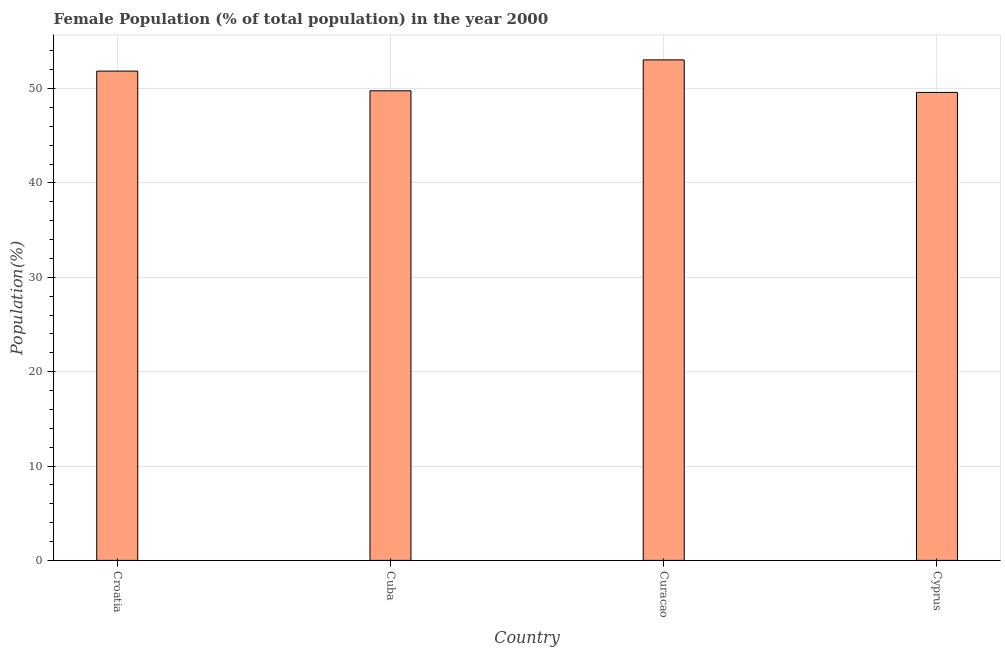Does the graph contain any zero values?
Make the answer very short. No. Does the graph contain grids?
Keep it short and to the point. Yes. What is the title of the graph?
Provide a succinct answer. Female Population (% of total population) in the year 2000. What is the label or title of the X-axis?
Make the answer very short. Country. What is the label or title of the Y-axis?
Ensure brevity in your answer.  Population(%). What is the female population in Cuba?
Ensure brevity in your answer.  49.77. Across all countries, what is the maximum female population?
Give a very brief answer. 53.05. Across all countries, what is the minimum female population?
Provide a short and direct response. 49.6. In which country was the female population maximum?
Your answer should be compact. Curacao. In which country was the female population minimum?
Make the answer very short. Cyprus. What is the sum of the female population?
Your answer should be very brief. 204.27. What is the difference between the female population in Croatia and Cyprus?
Offer a terse response. 2.26. What is the average female population per country?
Your answer should be compact. 51.07. What is the median female population?
Keep it short and to the point. 50.81. In how many countries, is the female population greater than 50 %?
Your response must be concise. 2. What is the ratio of the female population in Croatia to that in Cuba?
Provide a succinct answer. 1.04. Is the difference between the female population in Cuba and Curacao greater than the difference between any two countries?
Offer a very short reply. No. What is the difference between the highest and the second highest female population?
Keep it short and to the point. 1.19. Is the sum of the female population in Croatia and Cyprus greater than the maximum female population across all countries?
Keep it short and to the point. Yes. What is the difference between the highest and the lowest female population?
Provide a short and direct response. 3.45. In how many countries, is the female population greater than the average female population taken over all countries?
Make the answer very short. 2. Are all the bars in the graph horizontal?
Keep it short and to the point. No. What is the difference between two consecutive major ticks on the Y-axis?
Your answer should be compact. 10. What is the Population(%) of Croatia?
Make the answer very short. 51.86. What is the Population(%) in Cuba?
Provide a short and direct response. 49.77. What is the Population(%) in Curacao?
Give a very brief answer. 53.05. What is the Population(%) in Cyprus?
Offer a very short reply. 49.6. What is the difference between the Population(%) in Croatia and Cuba?
Provide a short and direct response. 2.09. What is the difference between the Population(%) in Croatia and Curacao?
Your response must be concise. -1.19. What is the difference between the Population(%) in Croatia and Cyprus?
Give a very brief answer. 2.26. What is the difference between the Population(%) in Cuba and Curacao?
Your response must be concise. -3.27. What is the difference between the Population(%) in Cuba and Cyprus?
Your answer should be compact. 0.17. What is the difference between the Population(%) in Curacao and Cyprus?
Provide a short and direct response. 3.45. What is the ratio of the Population(%) in Croatia to that in Cuba?
Your response must be concise. 1.04. What is the ratio of the Population(%) in Croatia to that in Cyprus?
Offer a very short reply. 1.05. What is the ratio of the Population(%) in Cuba to that in Curacao?
Make the answer very short. 0.94. What is the ratio of the Population(%) in Cuba to that in Cyprus?
Provide a short and direct response. 1. What is the ratio of the Population(%) in Curacao to that in Cyprus?
Offer a terse response. 1.07. 